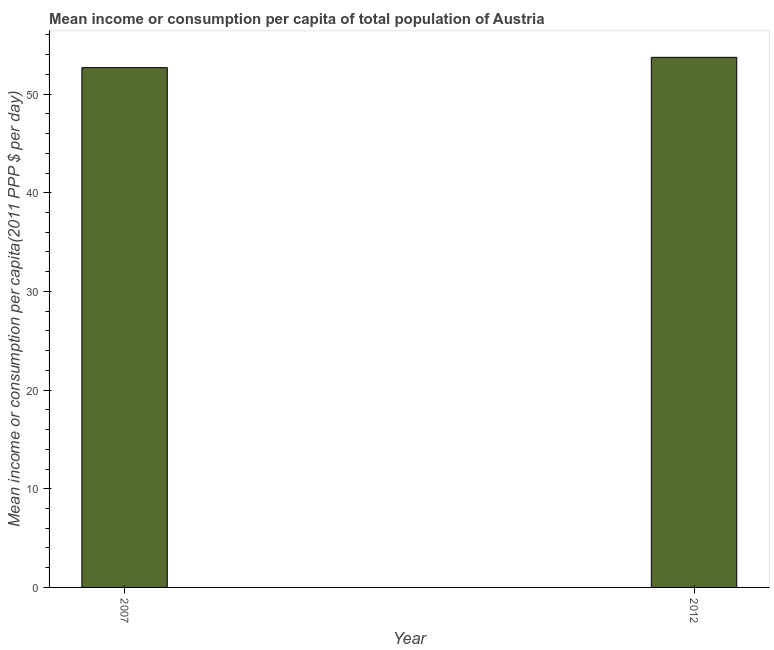Does the graph contain grids?
Your answer should be very brief. No. What is the title of the graph?
Offer a very short reply. Mean income or consumption per capita of total population of Austria. What is the label or title of the X-axis?
Make the answer very short. Year. What is the label or title of the Y-axis?
Your answer should be compact. Mean income or consumption per capita(2011 PPP $ per day). What is the mean income or consumption in 2007?
Ensure brevity in your answer.  52.68. Across all years, what is the maximum mean income or consumption?
Provide a succinct answer. 53.73. Across all years, what is the minimum mean income or consumption?
Offer a very short reply. 52.68. In which year was the mean income or consumption maximum?
Your answer should be very brief. 2012. In which year was the mean income or consumption minimum?
Offer a terse response. 2007. What is the sum of the mean income or consumption?
Your answer should be very brief. 106.41. What is the difference between the mean income or consumption in 2007 and 2012?
Your answer should be very brief. -1.04. What is the average mean income or consumption per year?
Ensure brevity in your answer.  53.21. What is the median mean income or consumption?
Your answer should be compact. 53.21. In how many years, is the mean income or consumption greater than 28 $?
Your answer should be compact. 2. What is the ratio of the mean income or consumption in 2007 to that in 2012?
Your answer should be very brief. 0.98. Is the mean income or consumption in 2007 less than that in 2012?
Your answer should be compact. Yes. Are all the bars in the graph horizontal?
Make the answer very short. No. Are the values on the major ticks of Y-axis written in scientific E-notation?
Your response must be concise. No. What is the Mean income or consumption per capita(2011 PPP $ per day) in 2007?
Keep it short and to the point. 52.68. What is the Mean income or consumption per capita(2011 PPP $ per day) in 2012?
Your answer should be very brief. 53.73. What is the difference between the Mean income or consumption per capita(2011 PPP $ per day) in 2007 and 2012?
Provide a short and direct response. -1.04. What is the ratio of the Mean income or consumption per capita(2011 PPP $ per day) in 2007 to that in 2012?
Keep it short and to the point. 0.98. 